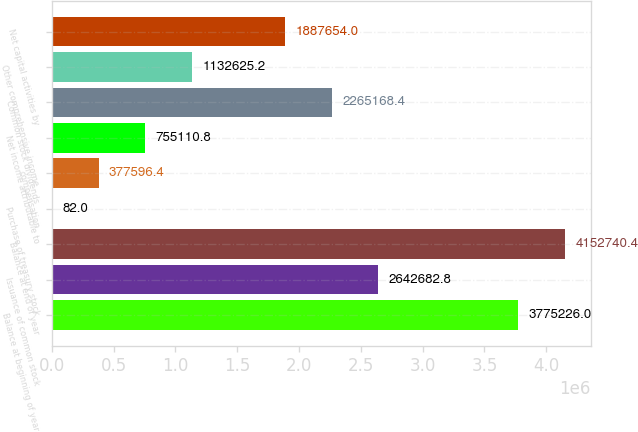Convert chart to OTSL. <chart><loc_0><loc_0><loc_500><loc_500><bar_chart><fcel>Balance at beginning of year<fcel>Issuance of common stock<fcel>Balance at end of year<fcel>Purchase of treasury stock<fcel>compensation<fcel>Net income attributable to<fcel>Common stock dividends<fcel>Other comprehensive income<fcel>Net capital activities by<nl><fcel>3.77523e+06<fcel>2.64268e+06<fcel>4.15274e+06<fcel>82<fcel>377596<fcel>755111<fcel>2.26517e+06<fcel>1.13263e+06<fcel>1.88765e+06<nl></chart> 